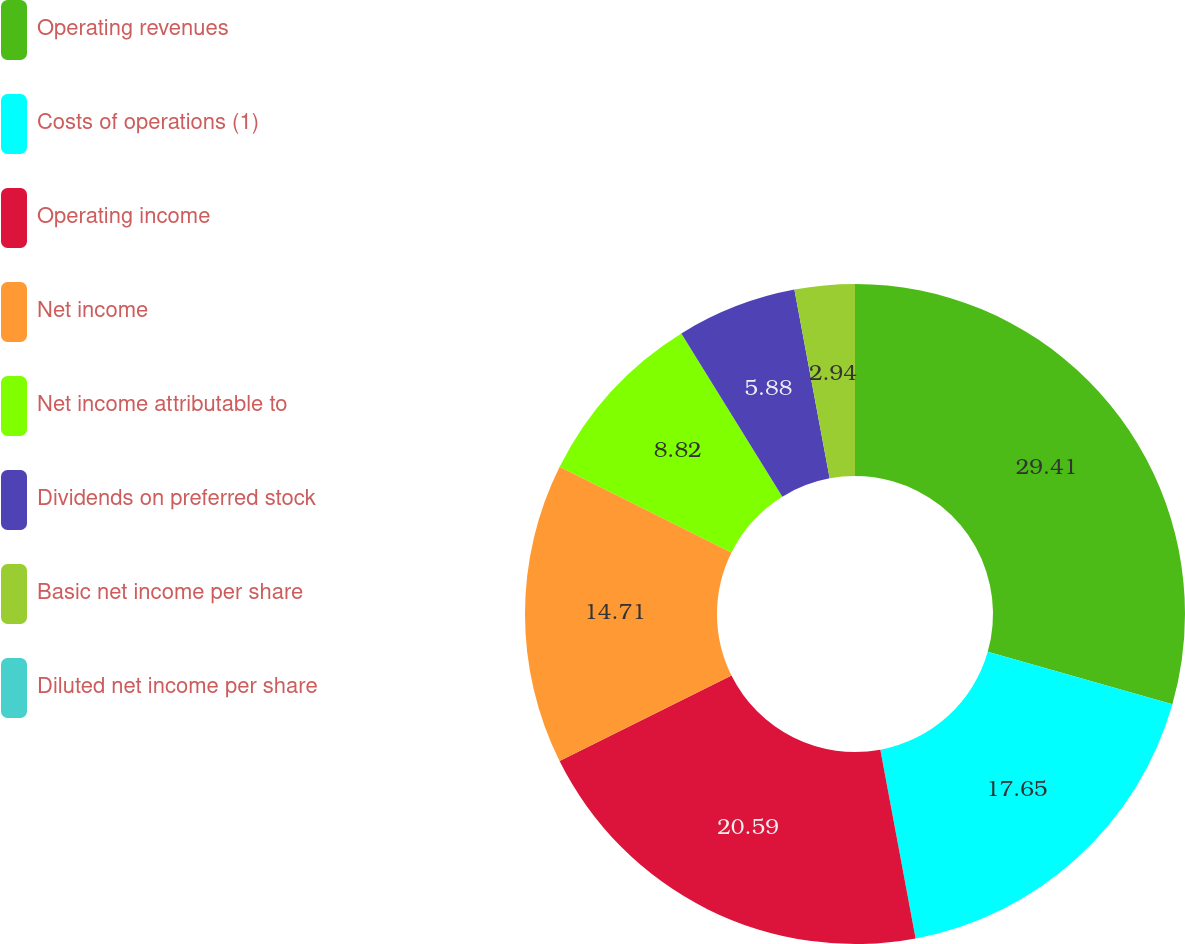Convert chart. <chart><loc_0><loc_0><loc_500><loc_500><pie_chart><fcel>Operating revenues<fcel>Costs of operations (1)<fcel>Operating income<fcel>Net income<fcel>Net income attributable to<fcel>Dividends on preferred stock<fcel>Basic net income per share<fcel>Diluted net income per share<nl><fcel>29.41%<fcel>17.65%<fcel>20.59%<fcel>14.71%<fcel>8.82%<fcel>5.88%<fcel>2.94%<fcel>0.0%<nl></chart> 